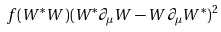Convert formula to latex. <formula><loc_0><loc_0><loc_500><loc_500>f ( W ^ { * } W ) ( W ^ { * } \partial _ { \mu } W - W \partial _ { \mu } W ^ { * } ) ^ { 2 }</formula> 